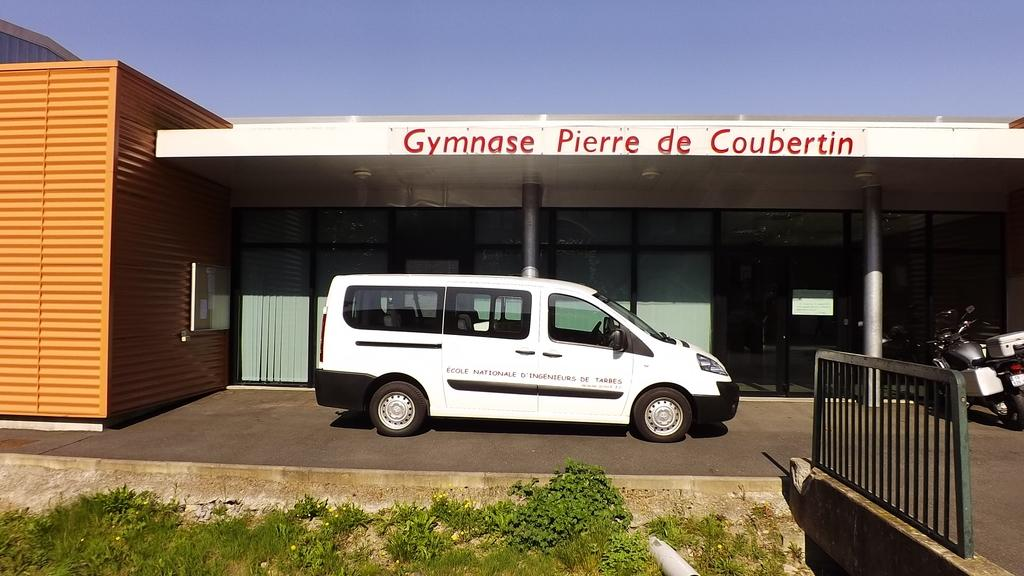<image>
Share a concise interpretation of the image provided. A white van in front of a building that says Gymnase Pierre de Coubertin. 